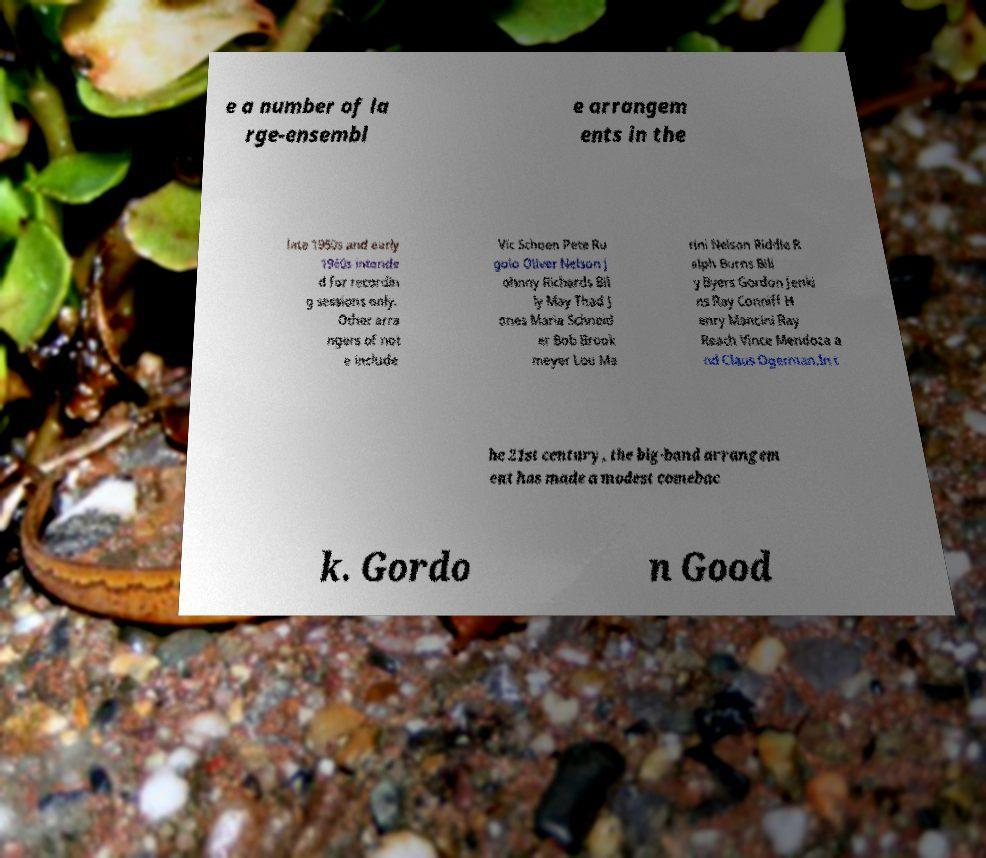There's text embedded in this image that I need extracted. Can you transcribe it verbatim? e a number of la rge-ensembl e arrangem ents in the late 1950s and early 1960s intende d for recordin g sessions only. Other arra ngers of not e include Vic Schoen Pete Ru golo Oliver Nelson J ohnny Richards Bil ly May Thad J ones Maria Schneid er Bob Brook meyer Lou Ma rini Nelson Riddle R alph Burns Bill y Byers Gordon Jenki ns Ray Conniff H enry Mancini Ray Reach Vince Mendoza a nd Claus Ogerman.In t he 21st century, the big-band arrangem ent has made a modest comebac k. Gordo n Good 